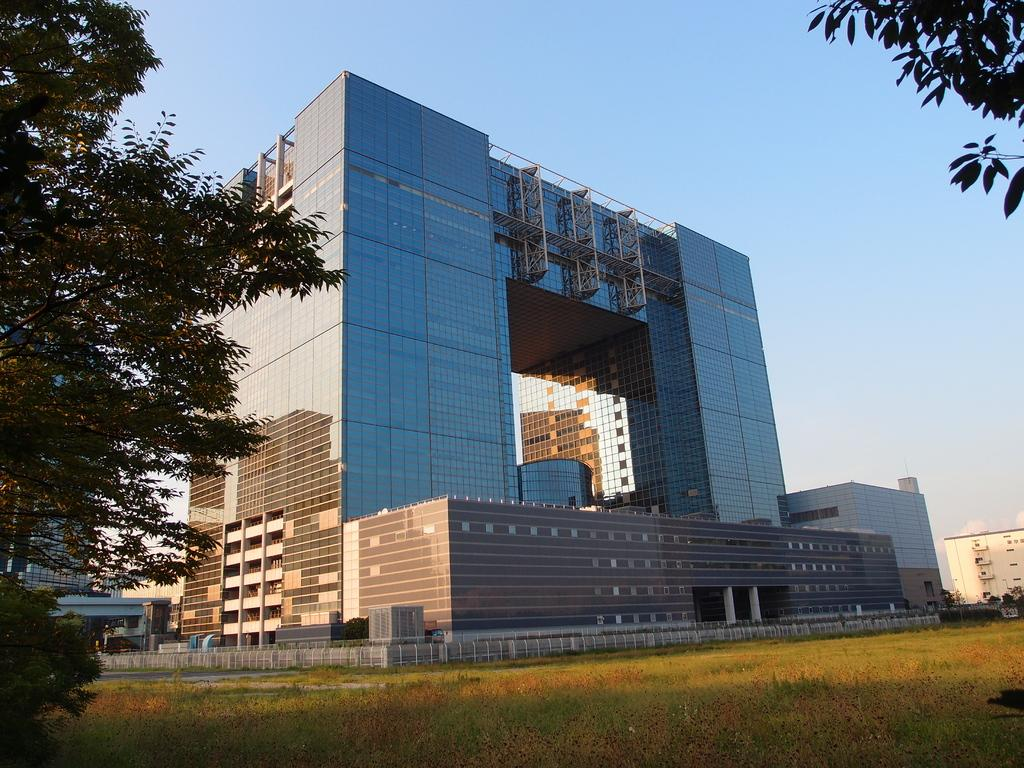What type of vegetation is present in the image? There is grass in the image. Where is the tree located in the image? The tree is on the left side of the image. What can be seen in the background of the image? There are buildings and the sky visible in the background of the image. What team is responsible for maintaining the room in the image? There is no room present in the image, as it features grass, a tree, buildings, and the sky. 